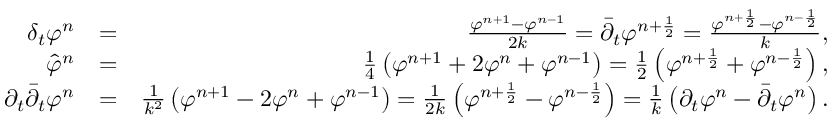Convert formula to latex. <formula><loc_0><loc_0><loc_500><loc_500>\begin{array} { r l r } { \delta _ { t } \varphi ^ { n } } & { = } & { \frac { \varphi ^ { n + 1 } - \varphi ^ { n - 1 } } { 2 k } = { \bar { \partial } } _ { t } \varphi ^ { n + \frac { 1 } { 2 } } = \frac { \varphi ^ { n + \frac { 1 } { 2 } } - \varphi ^ { n - \frac { 1 } { 2 } } } { k } , } \\ { { \hat { \varphi } } ^ { n } } & { = } & { \frac { 1 } { 4 } \left ( \varphi ^ { n + 1 } + 2 \varphi ^ { n } + \varphi ^ { n - 1 } \right ) = \frac { 1 } { 2 } \left ( \varphi ^ { n + \frac { 1 } { 2 } } + \varphi ^ { n - \frac { 1 } { 2 } } \right ) , } \\ { \partial _ { t } { \bar { \partial } } _ { t } \varphi ^ { n } } & { = } & { \frac { 1 } { k ^ { 2 } } \left ( \varphi ^ { n + 1 } - 2 \varphi ^ { n } + \varphi ^ { n - 1 } \right ) = \frac { 1 } { 2 k } \left ( \varphi ^ { n + \frac { 1 } { 2 } } - \varphi ^ { n - \frac { 1 } { 2 } } \right ) = \frac { 1 } { k } \left ( \partial _ { t } \varphi ^ { n } - { \bar { \partial } } _ { t } \varphi ^ { n } \right ) . } \end{array}</formula> 